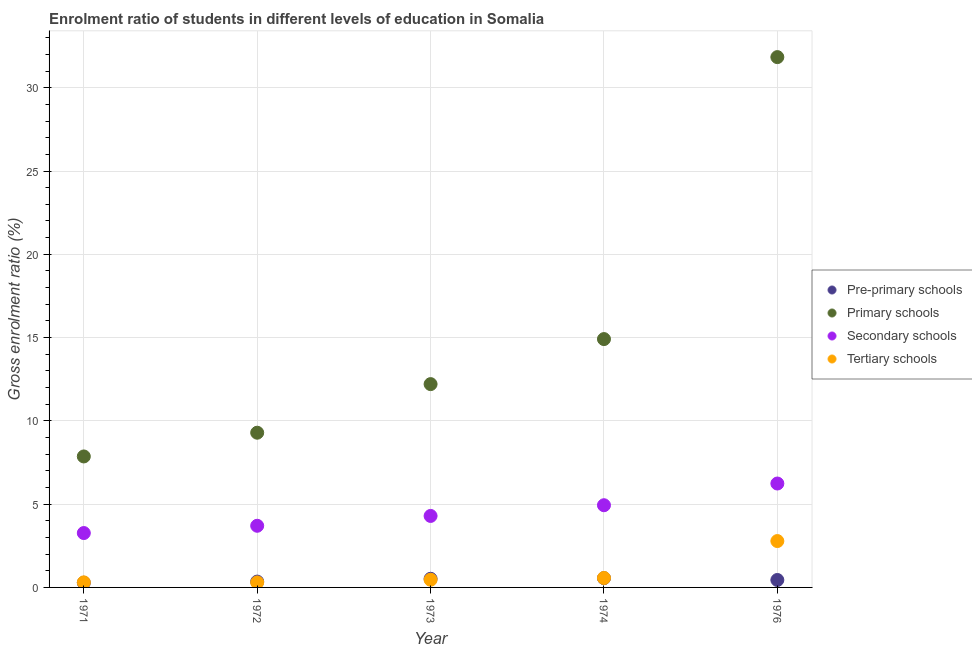How many different coloured dotlines are there?
Your answer should be very brief. 4. What is the gross enrolment ratio in pre-primary schools in 1971?
Make the answer very short. 0.28. Across all years, what is the maximum gross enrolment ratio in pre-primary schools?
Provide a short and direct response. 0.56. Across all years, what is the minimum gross enrolment ratio in pre-primary schools?
Ensure brevity in your answer.  0.28. In which year was the gross enrolment ratio in secondary schools maximum?
Offer a terse response. 1976. What is the total gross enrolment ratio in secondary schools in the graph?
Your response must be concise. 22.43. What is the difference between the gross enrolment ratio in primary schools in 1971 and that in 1974?
Your answer should be compact. -7.05. What is the difference between the gross enrolment ratio in tertiary schools in 1976 and the gross enrolment ratio in pre-primary schools in 1971?
Give a very brief answer. 2.5. What is the average gross enrolment ratio in secondary schools per year?
Make the answer very short. 4.49. In the year 1971, what is the difference between the gross enrolment ratio in pre-primary schools and gross enrolment ratio in primary schools?
Offer a very short reply. -7.58. What is the ratio of the gross enrolment ratio in secondary schools in 1971 to that in 1974?
Offer a terse response. 0.66. Is the gross enrolment ratio in pre-primary schools in 1971 less than that in 1974?
Ensure brevity in your answer.  Yes. Is the difference between the gross enrolment ratio in primary schools in 1972 and 1976 greater than the difference between the gross enrolment ratio in pre-primary schools in 1972 and 1976?
Your response must be concise. No. What is the difference between the highest and the second highest gross enrolment ratio in secondary schools?
Offer a terse response. 1.3. What is the difference between the highest and the lowest gross enrolment ratio in primary schools?
Ensure brevity in your answer.  23.98. Is it the case that in every year, the sum of the gross enrolment ratio in pre-primary schools and gross enrolment ratio in primary schools is greater than the gross enrolment ratio in secondary schools?
Make the answer very short. Yes. Is the gross enrolment ratio in tertiary schools strictly less than the gross enrolment ratio in primary schools over the years?
Ensure brevity in your answer.  Yes. How many years are there in the graph?
Offer a terse response. 5. What is the difference between two consecutive major ticks on the Y-axis?
Give a very brief answer. 5. Does the graph contain grids?
Your answer should be compact. Yes. How many legend labels are there?
Offer a very short reply. 4. What is the title of the graph?
Offer a very short reply. Enrolment ratio of students in different levels of education in Somalia. Does "Corruption" appear as one of the legend labels in the graph?
Offer a very short reply. No. What is the Gross enrolment ratio (%) of Pre-primary schools in 1971?
Keep it short and to the point. 0.28. What is the Gross enrolment ratio (%) in Primary schools in 1971?
Your answer should be very brief. 7.86. What is the Gross enrolment ratio (%) in Secondary schools in 1971?
Keep it short and to the point. 3.26. What is the Gross enrolment ratio (%) of Tertiary schools in 1971?
Give a very brief answer. 0.3. What is the Gross enrolment ratio (%) of Pre-primary schools in 1972?
Provide a succinct answer. 0.35. What is the Gross enrolment ratio (%) in Primary schools in 1972?
Your response must be concise. 9.29. What is the Gross enrolment ratio (%) of Secondary schools in 1972?
Your answer should be compact. 3.7. What is the Gross enrolment ratio (%) of Tertiary schools in 1972?
Provide a succinct answer. 0.3. What is the Gross enrolment ratio (%) of Pre-primary schools in 1973?
Make the answer very short. 0.52. What is the Gross enrolment ratio (%) of Primary schools in 1973?
Provide a succinct answer. 12.21. What is the Gross enrolment ratio (%) in Secondary schools in 1973?
Make the answer very short. 4.29. What is the Gross enrolment ratio (%) of Tertiary schools in 1973?
Offer a terse response. 0.46. What is the Gross enrolment ratio (%) in Pre-primary schools in 1974?
Provide a succinct answer. 0.56. What is the Gross enrolment ratio (%) in Primary schools in 1974?
Give a very brief answer. 14.91. What is the Gross enrolment ratio (%) of Secondary schools in 1974?
Provide a short and direct response. 4.94. What is the Gross enrolment ratio (%) in Tertiary schools in 1974?
Keep it short and to the point. 0.57. What is the Gross enrolment ratio (%) in Pre-primary schools in 1976?
Your response must be concise. 0.45. What is the Gross enrolment ratio (%) of Primary schools in 1976?
Keep it short and to the point. 31.84. What is the Gross enrolment ratio (%) in Secondary schools in 1976?
Your answer should be compact. 6.24. What is the Gross enrolment ratio (%) in Tertiary schools in 1976?
Keep it short and to the point. 2.78. Across all years, what is the maximum Gross enrolment ratio (%) in Pre-primary schools?
Your answer should be very brief. 0.56. Across all years, what is the maximum Gross enrolment ratio (%) of Primary schools?
Offer a terse response. 31.84. Across all years, what is the maximum Gross enrolment ratio (%) of Secondary schools?
Your response must be concise. 6.24. Across all years, what is the maximum Gross enrolment ratio (%) in Tertiary schools?
Give a very brief answer. 2.78. Across all years, what is the minimum Gross enrolment ratio (%) of Pre-primary schools?
Keep it short and to the point. 0.28. Across all years, what is the minimum Gross enrolment ratio (%) of Primary schools?
Ensure brevity in your answer.  7.86. Across all years, what is the minimum Gross enrolment ratio (%) in Secondary schools?
Ensure brevity in your answer.  3.26. Across all years, what is the minimum Gross enrolment ratio (%) of Tertiary schools?
Your response must be concise. 0.3. What is the total Gross enrolment ratio (%) in Pre-primary schools in the graph?
Make the answer very short. 2.15. What is the total Gross enrolment ratio (%) of Primary schools in the graph?
Provide a short and direct response. 76.11. What is the total Gross enrolment ratio (%) of Secondary schools in the graph?
Your answer should be very brief. 22.43. What is the total Gross enrolment ratio (%) in Tertiary schools in the graph?
Provide a short and direct response. 4.42. What is the difference between the Gross enrolment ratio (%) in Pre-primary schools in 1971 and that in 1972?
Make the answer very short. -0.07. What is the difference between the Gross enrolment ratio (%) of Primary schools in 1971 and that in 1972?
Offer a terse response. -1.43. What is the difference between the Gross enrolment ratio (%) of Secondary schools in 1971 and that in 1972?
Keep it short and to the point. -0.44. What is the difference between the Gross enrolment ratio (%) in Tertiary schools in 1971 and that in 1972?
Make the answer very short. 0. What is the difference between the Gross enrolment ratio (%) in Pre-primary schools in 1971 and that in 1973?
Make the answer very short. -0.24. What is the difference between the Gross enrolment ratio (%) in Primary schools in 1971 and that in 1973?
Keep it short and to the point. -4.34. What is the difference between the Gross enrolment ratio (%) in Secondary schools in 1971 and that in 1973?
Your response must be concise. -1.03. What is the difference between the Gross enrolment ratio (%) in Tertiary schools in 1971 and that in 1973?
Keep it short and to the point. -0.16. What is the difference between the Gross enrolment ratio (%) of Pre-primary schools in 1971 and that in 1974?
Ensure brevity in your answer.  -0.28. What is the difference between the Gross enrolment ratio (%) in Primary schools in 1971 and that in 1974?
Your answer should be very brief. -7.05. What is the difference between the Gross enrolment ratio (%) in Secondary schools in 1971 and that in 1974?
Give a very brief answer. -1.67. What is the difference between the Gross enrolment ratio (%) in Tertiary schools in 1971 and that in 1974?
Your answer should be compact. -0.26. What is the difference between the Gross enrolment ratio (%) in Primary schools in 1971 and that in 1976?
Keep it short and to the point. -23.98. What is the difference between the Gross enrolment ratio (%) in Secondary schools in 1971 and that in 1976?
Provide a short and direct response. -2.97. What is the difference between the Gross enrolment ratio (%) in Tertiary schools in 1971 and that in 1976?
Your answer should be very brief. -2.48. What is the difference between the Gross enrolment ratio (%) of Pre-primary schools in 1972 and that in 1973?
Provide a short and direct response. -0.17. What is the difference between the Gross enrolment ratio (%) of Primary schools in 1972 and that in 1973?
Keep it short and to the point. -2.92. What is the difference between the Gross enrolment ratio (%) of Secondary schools in 1972 and that in 1973?
Make the answer very short. -0.59. What is the difference between the Gross enrolment ratio (%) of Tertiary schools in 1972 and that in 1973?
Your response must be concise. -0.16. What is the difference between the Gross enrolment ratio (%) of Pre-primary schools in 1972 and that in 1974?
Your answer should be very brief. -0.21. What is the difference between the Gross enrolment ratio (%) in Primary schools in 1972 and that in 1974?
Keep it short and to the point. -5.62. What is the difference between the Gross enrolment ratio (%) of Secondary schools in 1972 and that in 1974?
Give a very brief answer. -1.23. What is the difference between the Gross enrolment ratio (%) in Tertiary schools in 1972 and that in 1974?
Ensure brevity in your answer.  -0.27. What is the difference between the Gross enrolment ratio (%) of Pre-primary schools in 1972 and that in 1976?
Offer a terse response. -0.1. What is the difference between the Gross enrolment ratio (%) of Primary schools in 1972 and that in 1976?
Your answer should be very brief. -22.55. What is the difference between the Gross enrolment ratio (%) of Secondary schools in 1972 and that in 1976?
Provide a short and direct response. -2.54. What is the difference between the Gross enrolment ratio (%) of Tertiary schools in 1972 and that in 1976?
Your answer should be very brief. -2.48. What is the difference between the Gross enrolment ratio (%) of Pre-primary schools in 1973 and that in 1974?
Ensure brevity in your answer.  -0.04. What is the difference between the Gross enrolment ratio (%) of Primary schools in 1973 and that in 1974?
Offer a terse response. -2.7. What is the difference between the Gross enrolment ratio (%) in Secondary schools in 1973 and that in 1974?
Your answer should be very brief. -0.64. What is the difference between the Gross enrolment ratio (%) of Tertiary schools in 1973 and that in 1974?
Offer a terse response. -0.11. What is the difference between the Gross enrolment ratio (%) in Pre-primary schools in 1973 and that in 1976?
Give a very brief answer. 0.07. What is the difference between the Gross enrolment ratio (%) of Primary schools in 1973 and that in 1976?
Your response must be concise. -19.63. What is the difference between the Gross enrolment ratio (%) of Secondary schools in 1973 and that in 1976?
Make the answer very short. -1.95. What is the difference between the Gross enrolment ratio (%) of Tertiary schools in 1973 and that in 1976?
Offer a very short reply. -2.32. What is the difference between the Gross enrolment ratio (%) of Pre-primary schools in 1974 and that in 1976?
Offer a terse response. 0.11. What is the difference between the Gross enrolment ratio (%) in Primary schools in 1974 and that in 1976?
Make the answer very short. -16.93. What is the difference between the Gross enrolment ratio (%) of Secondary schools in 1974 and that in 1976?
Make the answer very short. -1.3. What is the difference between the Gross enrolment ratio (%) of Tertiary schools in 1974 and that in 1976?
Provide a succinct answer. -2.22. What is the difference between the Gross enrolment ratio (%) of Pre-primary schools in 1971 and the Gross enrolment ratio (%) of Primary schools in 1972?
Your answer should be very brief. -9.01. What is the difference between the Gross enrolment ratio (%) in Pre-primary schools in 1971 and the Gross enrolment ratio (%) in Secondary schools in 1972?
Provide a short and direct response. -3.42. What is the difference between the Gross enrolment ratio (%) in Pre-primary schools in 1971 and the Gross enrolment ratio (%) in Tertiary schools in 1972?
Your response must be concise. -0.02. What is the difference between the Gross enrolment ratio (%) in Primary schools in 1971 and the Gross enrolment ratio (%) in Secondary schools in 1972?
Offer a very short reply. 4.16. What is the difference between the Gross enrolment ratio (%) of Primary schools in 1971 and the Gross enrolment ratio (%) of Tertiary schools in 1972?
Ensure brevity in your answer.  7.56. What is the difference between the Gross enrolment ratio (%) in Secondary schools in 1971 and the Gross enrolment ratio (%) in Tertiary schools in 1972?
Keep it short and to the point. 2.97. What is the difference between the Gross enrolment ratio (%) of Pre-primary schools in 1971 and the Gross enrolment ratio (%) of Primary schools in 1973?
Your response must be concise. -11.93. What is the difference between the Gross enrolment ratio (%) in Pre-primary schools in 1971 and the Gross enrolment ratio (%) in Secondary schools in 1973?
Your answer should be very brief. -4.01. What is the difference between the Gross enrolment ratio (%) in Pre-primary schools in 1971 and the Gross enrolment ratio (%) in Tertiary schools in 1973?
Keep it short and to the point. -0.18. What is the difference between the Gross enrolment ratio (%) in Primary schools in 1971 and the Gross enrolment ratio (%) in Secondary schools in 1973?
Offer a very short reply. 3.57. What is the difference between the Gross enrolment ratio (%) of Primary schools in 1971 and the Gross enrolment ratio (%) of Tertiary schools in 1973?
Your answer should be very brief. 7.4. What is the difference between the Gross enrolment ratio (%) in Secondary schools in 1971 and the Gross enrolment ratio (%) in Tertiary schools in 1973?
Your answer should be very brief. 2.8. What is the difference between the Gross enrolment ratio (%) of Pre-primary schools in 1971 and the Gross enrolment ratio (%) of Primary schools in 1974?
Offer a terse response. -14.63. What is the difference between the Gross enrolment ratio (%) in Pre-primary schools in 1971 and the Gross enrolment ratio (%) in Secondary schools in 1974?
Keep it short and to the point. -4.66. What is the difference between the Gross enrolment ratio (%) in Pre-primary schools in 1971 and the Gross enrolment ratio (%) in Tertiary schools in 1974?
Provide a succinct answer. -0.29. What is the difference between the Gross enrolment ratio (%) of Primary schools in 1971 and the Gross enrolment ratio (%) of Secondary schools in 1974?
Your answer should be compact. 2.93. What is the difference between the Gross enrolment ratio (%) of Primary schools in 1971 and the Gross enrolment ratio (%) of Tertiary schools in 1974?
Your answer should be very brief. 7.3. What is the difference between the Gross enrolment ratio (%) of Secondary schools in 1971 and the Gross enrolment ratio (%) of Tertiary schools in 1974?
Offer a terse response. 2.7. What is the difference between the Gross enrolment ratio (%) of Pre-primary schools in 1971 and the Gross enrolment ratio (%) of Primary schools in 1976?
Provide a short and direct response. -31.56. What is the difference between the Gross enrolment ratio (%) in Pre-primary schools in 1971 and the Gross enrolment ratio (%) in Secondary schools in 1976?
Your answer should be compact. -5.96. What is the difference between the Gross enrolment ratio (%) in Pre-primary schools in 1971 and the Gross enrolment ratio (%) in Tertiary schools in 1976?
Make the answer very short. -2.5. What is the difference between the Gross enrolment ratio (%) of Primary schools in 1971 and the Gross enrolment ratio (%) of Secondary schools in 1976?
Offer a terse response. 1.63. What is the difference between the Gross enrolment ratio (%) of Primary schools in 1971 and the Gross enrolment ratio (%) of Tertiary schools in 1976?
Offer a very short reply. 5.08. What is the difference between the Gross enrolment ratio (%) of Secondary schools in 1971 and the Gross enrolment ratio (%) of Tertiary schools in 1976?
Offer a terse response. 0.48. What is the difference between the Gross enrolment ratio (%) of Pre-primary schools in 1972 and the Gross enrolment ratio (%) of Primary schools in 1973?
Your answer should be very brief. -11.86. What is the difference between the Gross enrolment ratio (%) of Pre-primary schools in 1972 and the Gross enrolment ratio (%) of Secondary schools in 1973?
Keep it short and to the point. -3.94. What is the difference between the Gross enrolment ratio (%) in Pre-primary schools in 1972 and the Gross enrolment ratio (%) in Tertiary schools in 1973?
Ensure brevity in your answer.  -0.11. What is the difference between the Gross enrolment ratio (%) of Primary schools in 1972 and the Gross enrolment ratio (%) of Secondary schools in 1973?
Give a very brief answer. 5. What is the difference between the Gross enrolment ratio (%) in Primary schools in 1972 and the Gross enrolment ratio (%) in Tertiary schools in 1973?
Provide a succinct answer. 8.83. What is the difference between the Gross enrolment ratio (%) in Secondary schools in 1972 and the Gross enrolment ratio (%) in Tertiary schools in 1973?
Provide a succinct answer. 3.24. What is the difference between the Gross enrolment ratio (%) of Pre-primary schools in 1972 and the Gross enrolment ratio (%) of Primary schools in 1974?
Provide a succinct answer. -14.56. What is the difference between the Gross enrolment ratio (%) in Pre-primary schools in 1972 and the Gross enrolment ratio (%) in Secondary schools in 1974?
Your response must be concise. -4.58. What is the difference between the Gross enrolment ratio (%) in Pre-primary schools in 1972 and the Gross enrolment ratio (%) in Tertiary schools in 1974?
Give a very brief answer. -0.22. What is the difference between the Gross enrolment ratio (%) in Primary schools in 1972 and the Gross enrolment ratio (%) in Secondary schools in 1974?
Your answer should be very brief. 4.35. What is the difference between the Gross enrolment ratio (%) in Primary schools in 1972 and the Gross enrolment ratio (%) in Tertiary schools in 1974?
Offer a very short reply. 8.72. What is the difference between the Gross enrolment ratio (%) in Secondary schools in 1972 and the Gross enrolment ratio (%) in Tertiary schools in 1974?
Offer a terse response. 3.13. What is the difference between the Gross enrolment ratio (%) in Pre-primary schools in 1972 and the Gross enrolment ratio (%) in Primary schools in 1976?
Offer a terse response. -31.49. What is the difference between the Gross enrolment ratio (%) of Pre-primary schools in 1972 and the Gross enrolment ratio (%) of Secondary schools in 1976?
Provide a short and direct response. -5.89. What is the difference between the Gross enrolment ratio (%) of Pre-primary schools in 1972 and the Gross enrolment ratio (%) of Tertiary schools in 1976?
Ensure brevity in your answer.  -2.43. What is the difference between the Gross enrolment ratio (%) in Primary schools in 1972 and the Gross enrolment ratio (%) in Secondary schools in 1976?
Your answer should be very brief. 3.05. What is the difference between the Gross enrolment ratio (%) of Primary schools in 1972 and the Gross enrolment ratio (%) of Tertiary schools in 1976?
Provide a succinct answer. 6.5. What is the difference between the Gross enrolment ratio (%) of Secondary schools in 1972 and the Gross enrolment ratio (%) of Tertiary schools in 1976?
Your answer should be compact. 0.92. What is the difference between the Gross enrolment ratio (%) of Pre-primary schools in 1973 and the Gross enrolment ratio (%) of Primary schools in 1974?
Make the answer very short. -14.39. What is the difference between the Gross enrolment ratio (%) in Pre-primary schools in 1973 and the Gross enrolment ratio (%) in Secondary schools in 1974?
Make the answer very short. -4.42. What is the difference between the Gross enrolment ratio (%) in Pre-primary schools in 1973 and the Gross enrolment ratio (%) in Tertiary schools in 1974?
Offer a very short reply. -0.05. What is the difference between the Gross enrolment ratio (%) in Primary schools in 1973 and the Gross enrolment ratio (%) in Secondary schools in 1974?
Provide a succinct answer. 7.27. What is the difference between the Gross enrolment ratio (%) in Primary schools in 1973 and the Gross enrolment ratio (%) in Tertiary schools in 1974?
Your response must be concise. 11.64. What is the difference between the Gross enrolment ratio (%) in Secondary schools in 1973 and the Gross enrolment ratio (%) in Tertiary schools in 1974?
Keep it short and to the point. 3.72. What is the difference between the Gross enrolment ratio (%) of Pre-primary schools in 1973 and the Gross enrolment ratio (%) of Primary schools in 1976?
Provide a succinct answer. -31.32. What is the difference between the Gross enrolment ratio (%) of Pre-primary schools in 1973 and the Gross enrolment ratio (%) of Secondary schools in 1976?
Offer a very short reply. -5.72. What is the difference between the Gross enrolment ratio (%) of Pre-primary schools in 1973 and the Gross enrolment ratio (%) of Tertiary schools in 1976?
Provide a short and direct response. -2.26. What is the difference between the Gross enrolment ratio (%) in Primary schools in 1973 and the Gross enrolment ratio (%) in Secondary schools in 1976?
Your answer should be very brief. 5.97. What is the difference between the Gross enrolment ratio (%) in Primary schools in 1973 and the Gross enrolment ratio (%) in Tertiary schools in 1976?
Your answer should be compact. 9.42. What is the difference between the Gross enrolment ratio (%) in Secondary schools in 1973 and the Gross enrolment ratio (%) in Tertiary schools in 1976?
Your answer should be compact. 1.51. What is the difference between the Gross enrolment ratio (%) of Pre-primary schools in 1974 and the Gross enrolment ratio (%) of Primary schools in 1976?
Your response must be concise. -31.28. What is the difference between the Gross enrolment ratio (%) of Pre-primary schools in 1974 and the Gross enrolment ratio (%) of Secondary schools in 1976?
Your answer should be compact. -5.68. What is the difference between the Gross enrolment ratio (%) in Pre-primary schools in 1974 and the Gross enrolment ratio (%) in Tertiary schools in 1976?
Provide a succinct answer. -2.23. What is the difference between the Gross enrolment ratio (%) in Primary schools in 1974 and the Gross enrolment ratio (%) in Secondary schools in 1976?
Your answer should be compact. 8.67. What is the difference between the Gross enrolment ratio (%) in Primary schools in 1974 and the Gross enrolment ratio (%) in Tertiary schools in 1976?
Your answer should be very brief. 12.13. What is the difference between the Gross enrolment ratio (%) of Secondary schools in 1974 and the Gross enrolment ratio (%) of Tertiary schools in 1976?
Ensure brevity in your answer.  2.15. What is the average Gross enrolment ratio (%) in Pre-primary schools per year?
Offer a terse response. 0.43. What is the average Gross enrolment ratio (%) in Primary schools per year?
Ensure brevity in your answer.  15.22. What is the average Gross enrolment ratio (%) in Secondary schools per year?
Provide a short and direct response. 4.49. What is the average Gross enrolment ratio (%) of Tertiary schools per year?
Keep it short and to the point. 0.88. In the year 1971, what is the difference between the Gross enrolment ratio (%) in Pre-primary schools and Gross enrolment ratio (%) in Primary schools?
Offer a terse response. -7.58. In the year 1971, what is the difference between the Gross enrolment ratio (%) of Pre-primary schools and Gross enrolment ratio (%) of Secondary schools?
Offer a very short reply. -2.98. In the year 1971, what is the difference between the Gross enrolment ratio (%) of Pre-primary schools and Gross enrolment ratio (%) of Tertiary schools?
Ensure brevity in your answer.  -0.02. In the year 1971, what is the difference between the Gross enrolment ratio (%) in Primary schools and Gross enrolment ratio (%) in Secondary schools?
Your answer should be very brief. 4.6. In the year 1971, what is the difference between the Gross enrolment ratio (%) in Primary schools and Gross enrolment ratio (%) in Tertiary schools?
Your answer should be compact. 7.56. In the year 1971, what is the difference between the Gross enrolment ratio (%) of Secondary schools and Gross enrolment ratio (%) of Tertiary schools?
Your answer should be compact. 2.96. In the year 1972, what is the difference between the Gross enrolment ratio (%) in Pre-primary schools and Gross enrolment ratio (%) in Primary schools?
Provide a short and direct response. -8.94. In the year 1972, what is the difference between the Gross enrolment ratio (%) of Pre-primary schools and Gross enrolment ratio (%) of Secondary schools?
Make the answer very short. -3.35. In the year 1972, what is the difference between the Gross enrolment ratio (%) in Pre-primary schools and Gross enrolment ratio (%) in Tertiary schools?
Provide a succinct answer. 0.05. In the year 1972, what is the difference between the Gross enrolment ratio (%) in Primary schools and Gross enrolment ratio (%) in Secondary schools?
Your answer should be compact. 5.59. In the year 1972, what is the difference between the Gross enrolment ratio (%) in Primary schools and Gross enrolment ratio (%) in Tertiary schools?
Your answer should be compact. 8.99. In the year 1972, what is the difference between the Gross enrolment ratio (%) in Secondary schools and Gross enrolment ratio (%) in Tertiary schools?
Offer a very short reply. 3.4. In the year 1973, what is the difference between the Gross enrolment ratio (%) in Pre-primary schools and Gross enrolment ratio (%) in Primary schools?
Your answer should be compact. -11.69. In the year 1973, what is the difference between the Gross enrolment ratio (%) of Pre-primary schools and Gross enrolment ratio (%) of Secondary schools?
Your answer should be very brief. -3.77. In the year 1973, what is the difference between the Gross enrolment ratio (%) of Pre-primary schools and Gross enrolment ratio (%) of Tertiary schools?
Keep it short and to the point. 0.06. In the year 1973, what is the difference between the Gross enrolment ratio (%) of Primary schools and Gross enrolment ratio (%) of Secondary schools?
Make the answer very short. 7.91. In the year 1973, what is the difference between the Gross enrolment ratio (%) of Primary schools and Gross enrolment ratio (%) of Tertiary schools?
Your answer should be compact. 11.75. In the year 1973, what is the difference between the Gross enrolment ratio (%) of Secondary schools and Gross enrolment ratio (%) of Tertiary schools?
Your response must be concise. 3.83. In the year 1974, what is the difference between the Gross enrolment ratio (%) of Pre-primary schools and Gross enrolment ratio (%) of Primary schools?
Your answer should be very brief. -14.35. In the year 1974, what is the difference between the Gross enrolment ratio (%) of Pre-primary schools and Gross enrolment ratio (%) of Secondary schools?
Your answer should be very brief. -4.38. In the year 1974, what is the difference between the Gross enrolment ratio (%) of Pre-primary schools and Gross enrolment ratio (%) of Tertiary schools?
Give a very brief answer. -0.01. In the year 1974, what is the difference between the Gross enrolment ratio (%) of Primary schools and Gross enrolment ratio (%) of Secondary schools?
Provide a succinct answer. 9.97. In the year 1974, what is the difference between the Gross enrolment ratio (%) of Primary schools and Gross enrolment ratio (%) of Tertiary schools?
Offer a very short reply. 14.34. In the year 1974, what is the difference between the Gross enrolment ratio (%) of Secondary schools and Gross enrolment ratio (%) of Tertiary schools?
Ensure brevity in your answer.  4.37. In the year 1976, what is the difference between the Gross enrolment ratio (%) in Pre-primary schools and Gross enrolment ratio (%) in Primary schools?
Your answer should be very brief. -31.39. In the year 1976, what is the difference between the Gross enrolment ratio (%) of Pre-primary schools and Gross enrolment ratio (%) of Secondary schools?
Provide a succinct answer. -5.79. In the year 1976, what is the difference between the Gross enrolment ratio (%) of Pre-primary schools and Gross enrolment ratio (%) of Tertiary schools?
Your response must be concise. -2.34. In the year 1976, what is the difference between the Gross enrolment ratio (%) in Primary schools and Gross enrolment ratio (%) in Secondary schools?
Provide a short and direct response. 25.6. In the year 1976, what is the difference between the Gross enrolment ratio (%) in Primary schools and Gross enrolment ratio (%) in Tertiary schools?
Keep it short and to the point. 29.06. In the year 1976, what is the difference between the Gross enrolment ratio (%) of Secondary schools and Gross enrolment ratio (%) of Tertiary schools?
Your answer should be very brief. 3.45. What is the ratio of the Gross enrolment ratio (%) in Pre-primary schools in 1971 to that in 1972?
Offer a very short reply. 0.8. What is the ratio of the Gross enrolment ratio (%) of Primary schools in 1971 to that in 1972?
Ensure brevity in your answer.  0.85. What is the ratio of the Gross enrolment ratio (%) in Secondary schools in 1971 to that in 1972?
Your answer should be very brief. 0.88. What is the ratio of the Gross enrolment ratio (%) of Tertiary schools in 1971 to that in 1972?
Provide a succinct answer. 1.02. What is the ratio of the Gross enrolment ratio (%) in Pre-primary schools in 1971 to that in 1973?
Your response must be concise. 0.54. What is the ratio of the Gross enrolment ratio (%) in Primary schools in 1971 to that in 1973?
Offer a terse response. 0.64. What is the ratio of the Gross enrolment ratio (%) of Secondary schools in 1971 to that in 1973?
Ensure brevity in your answer.  0.76. What is the ratio of the Gross enrolment ratio (%) in Tertiary schools in 1971 to that in 1973?
Your answer should be compact. 0.66. What is the ratio of the Gross enrolment ratio (%) in Pre-primary schools in 1971 to that in 1974?
Keep it short and to the point. 0.5. What is the ratio of the Gross enrolment ratio (%) of Primary schools in 1971 to that in 1974?
Offer a terse response. 0.53. What is the ratio of the Gross enrolment ratio (%) in Secondary schools in 1971 to that in 1974?
Offer a terse response. 0.66. What is the ratio of the Gross enrolment ratio (%) in Tertiary schools in 1971 to that in 1974?
Offer a terse response. 0.54. What is the ratio of the Gross enrolment ratio (%) of Pre-primary schools in 1971 to that in 1976?
Provide a succinct answer. 0.63. What is the ratio of the Gross enrolment ratio (%) in Primary schools in 1971 to that in 1976?
Provide a succinct answer. 0.25. What is the ratio of the Gross enrolment ratio (%) of Secondary schools in 1971 to that in 1976?
Provide a succinct answer. 0.52. What is the ratio of the Gross enrolment ratio (%) of Tertiary schools in 1971 to that in 1976?
Provide a short and direct response. 0.11. What is the ratio of the Gross enrolment ratio (%) in Pre-primary schools in 1972 to that in 1973?
Make the answer very short. 0.67. What is the ratio of the Gross enrolment ratio (%) in Primary schools in 1972 to that in 1973?
Your answer should be very brief. 0.76. What is the ratio of the Gross enrolment ratio (%) of Secondary schools in 1972 to that in 1973?
Provide a short and direct response. 0.86. What is the ratio of the Gross enrolment ratio (%) of Tertiary schools in 1972 to that in 1973?
Provide a short and direct response. 0.65. What is the ratio of the Gross enrolment ratio (%) in Pre-primary schools in 1972 to that in 1974?
Offer a very short reply. 0.63. What is the ratio of the Gross enrolment ratio (%) in Primary schools in 1972 to that in 1974?
Provide a short and direct response. 0.62. What is the ratio of the Gross enrolment ratio (%) of Secondary schools in 1972 to that in 1974?
Offer a terse response. 0.75. What is the ratio of the Gross enrolment ratio (%) in Tertiary schools in 1972 to that in 1974?
Offer a very short reply. 0.53. What is the ratio of the Gross enrolment ratio (%) in Pre-primary schools in 1972 to that in 1976?
Make the answer very short. 0.78. What is the ratio of the Gross enrolment ratio (%) in Primary schools in 1972 to that in 1976?
Provide a succinct answer. 0.29. What is the ratio of the Gross enrolment ratio (%) in Secondary schools in 1972 to that in 1976?
Provide a short and direct response. 0.59. What is the ratio of the Gross enrolment ratio (%) of Tertiary schools in 1972 to that in 1976?
Provide a succinct answer. 0.11. What is the ratio of the Gross enrolment ratio (%) in Pre-primary schools in 1973 to that in 1974?
Ensure brevity in your answer.  0.93. What is the ratio of the Gross enrolment ratio (%) in Primary schools in 1973 to that in 1974?
Make the answer very short. 0.82. What is the ratio of the Gross enrolment ratio (%) of Secondary schools in 1973 to that in 1974?
Provide a short and direct response. 0.87. What is the ratio of the Gross enrolment ratio (%) of Tertiary schools in 1973 to that in 1974?
Give a very brief answer. 0.81. What is the ratio of the Gross enrolment ratio (%) in Pre-primary schools in 1973 to that in 1976?
Your answer should be very brief. 1.16. What is the ratio of the Gross enrolment ratio (%) in Primary schools in 1973 to that in 1976?
Make the answer very short. 0.38. What is the ratio of the Gross enrolment ratio (%) in Secondary schools in 1973 to that in 1976?
Keep it short and to the point. 0.69. What is the ratio of the Gross enrolment ratio (%) in Tertiary schools in 1973 to that in 1976?
Ensure brevity in your answer.  0.17. What is the ratio of the Gross enrolment ratio (%) in Pre-primary schools in 1974 to that in 1976?
Offer a terse response. 1.25. What is the ratio of the Gross enrolment ratio (%) in Primary schools in 1974 to that in 1976?
Give a very brief answer. 0.47. What is the ratio of the Gross enrolment ratio (%) in Secondary schools in 1974 to that in 1976?
Your response must be concise. 0.79. What is the ratio of the Gross enrolment ratio (%) of Tertiary schools in 1974 to that in 1976?
Ensure brevity in your answer.  0.2. What is the difference between the highest and the second highest Gross enrolment ratio (%) of Pre-primary schools?
Keep it short and to the point. 0.04. What is the difference between the highest and the second highest Gross enrolment ratio (%) of Primary schools?
Ensure brevity in your answer.  16.93. What is the difference between the highest and the second highest Gross enrolment ratio (%) of Secondary schools?
Provide a short and direct response. 1.3. What is the difference between the highest and the second highest Gross enrolment ratio (%) of Tertiary schools?
Keep it short and to the point. 2.22. What is the difference between the highest and the lowest Gross enrolment ratio (%) of Pre-primary schools?
Your answer should be very brief. 0.28. What is the difference between the highest and the lowest Gross enrolment ratio (%) of Primary schools?
Give a very brief answer. 23.98. What is the difference between the highest and the lowest Gross enrolment ratio (%) of Secondary schools?
Make the answer very short. 2.97. What is the difference between the highest and the lowest Gross enrolment ratio (%) in Tertiary schools?
Your answer should be very brief. 2.48. 